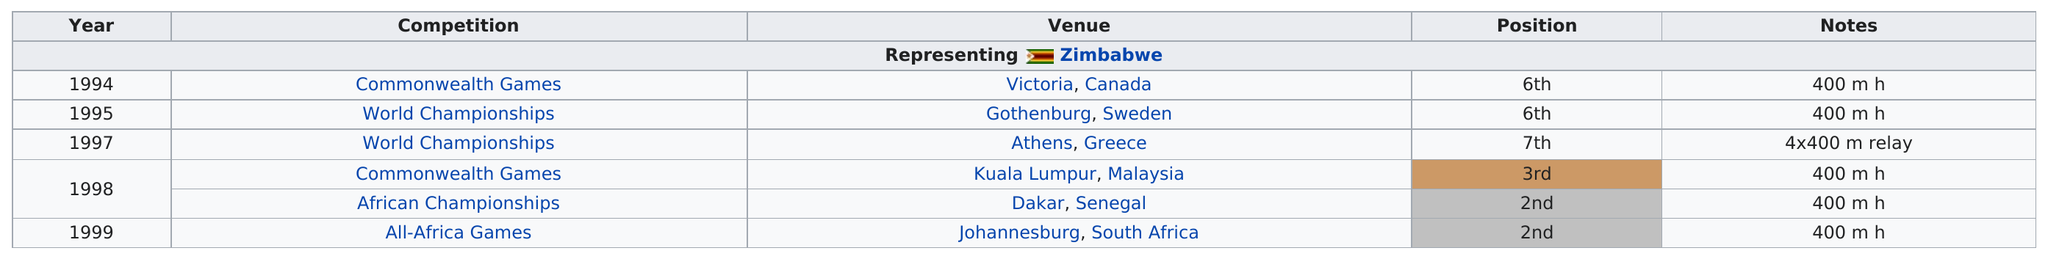Give some essential details in this illustration. Ken Harnden did better than fifth place in the years 1998 and 1999. The next venue after Athens, Greece was Kuala Lumpur, Malaysia. There are at least 5 venues on the chart, and they are all present. The All-Africa Games is the last competition shown on the chart. In the year 1998, there were the most competitions. 